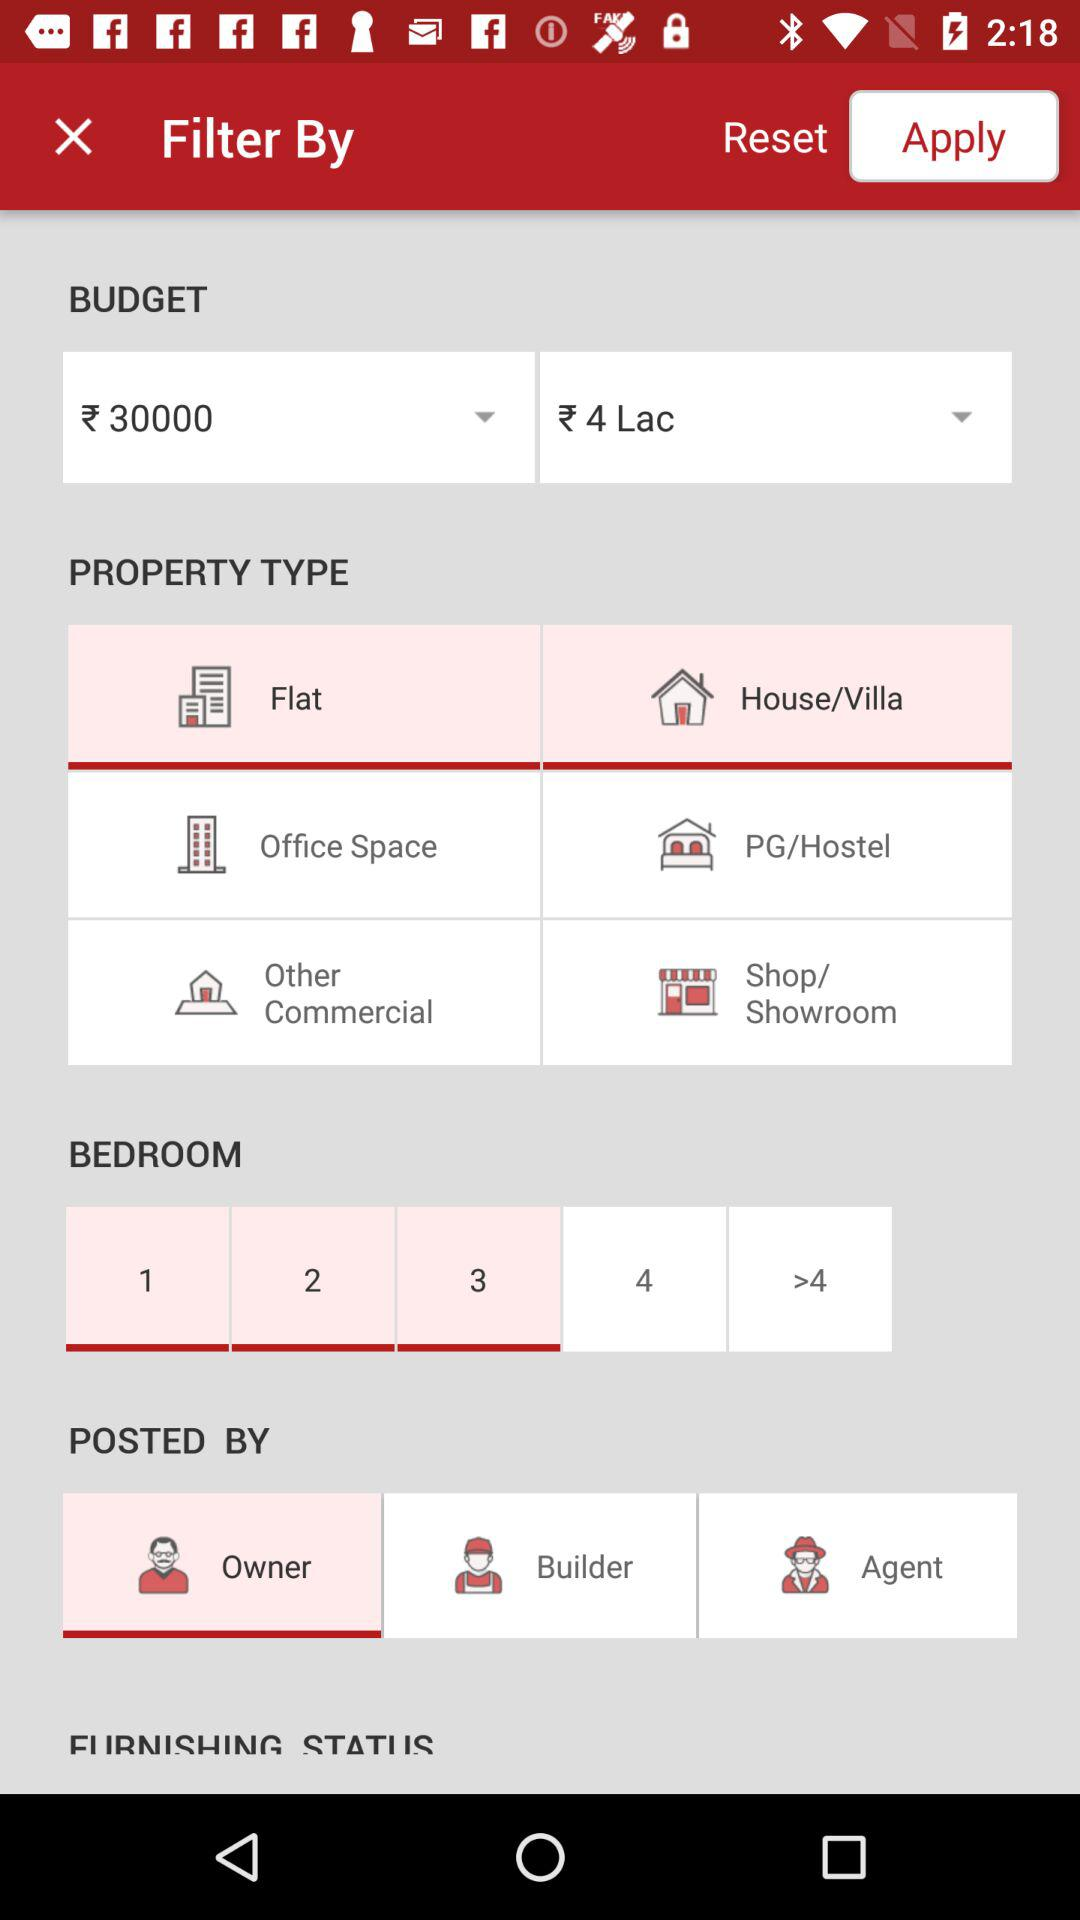How many rooms were selected? There were 3 rooms selected. 